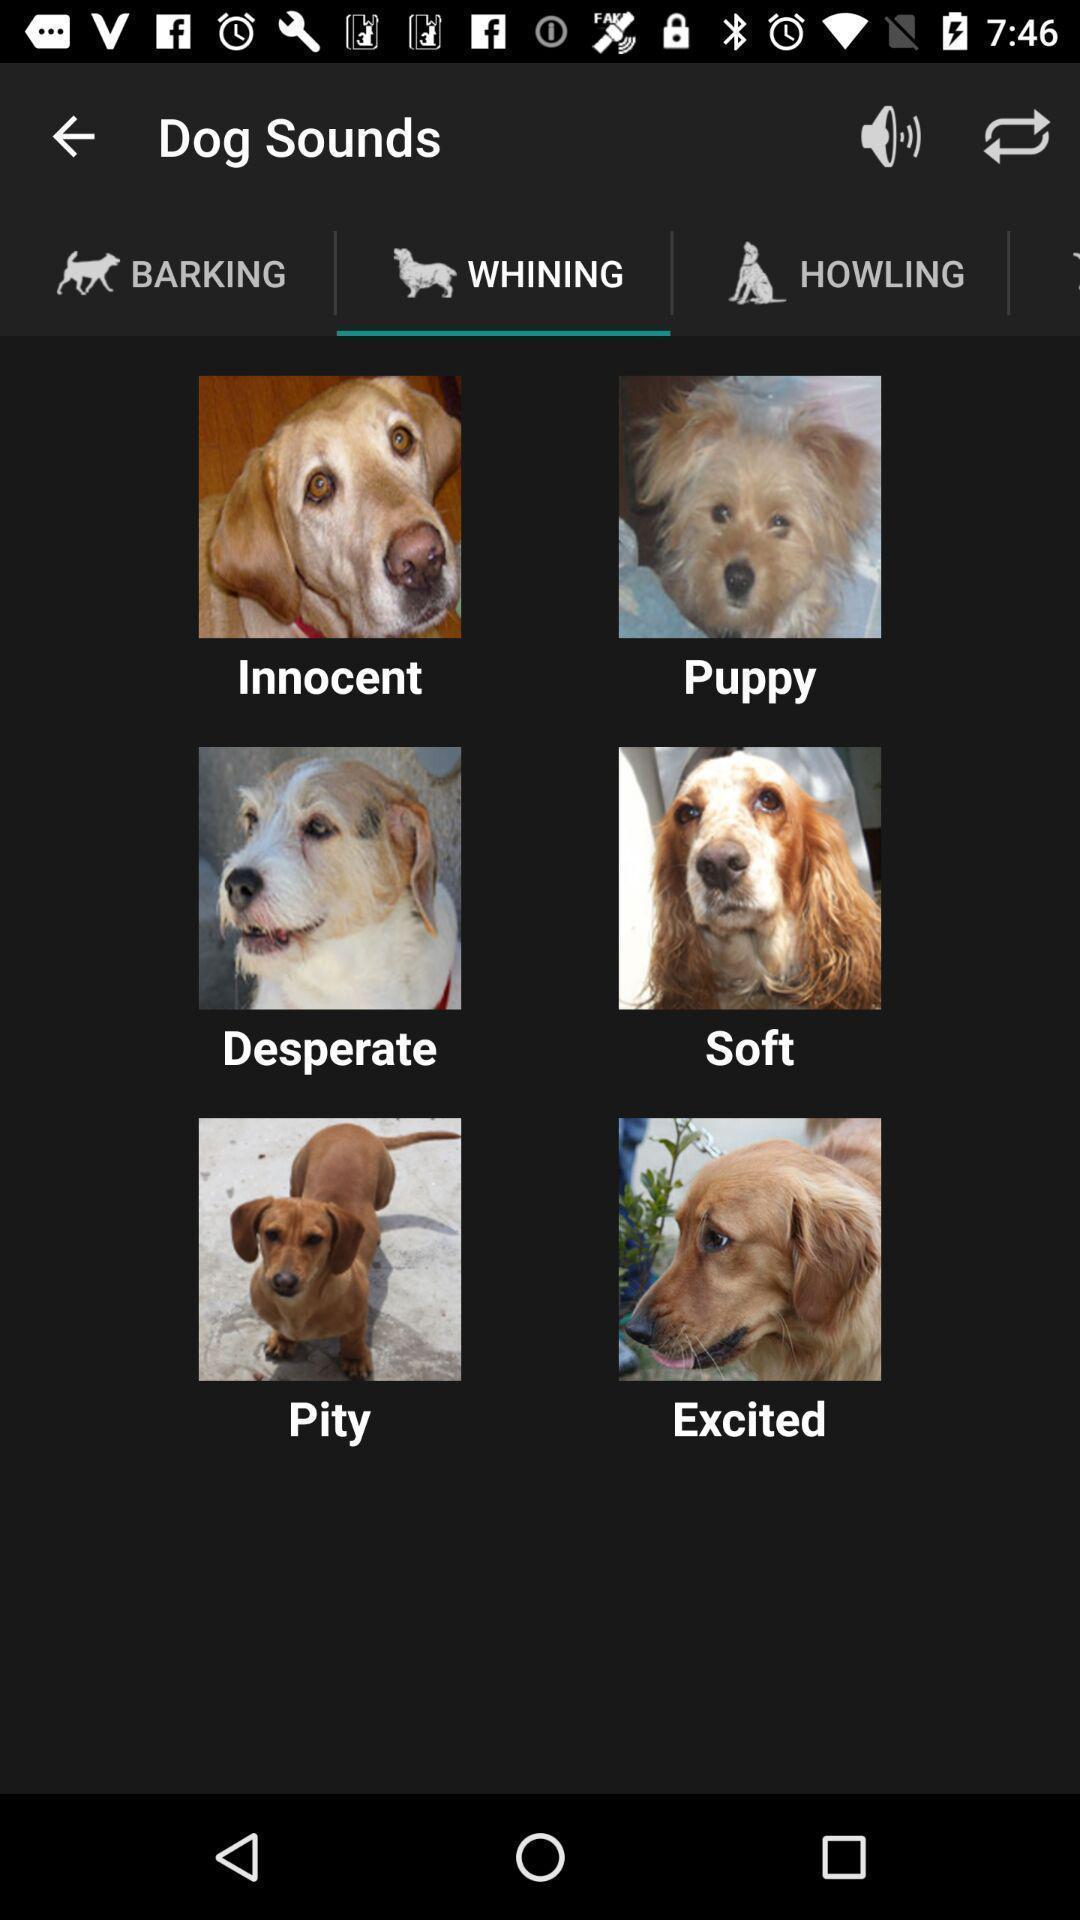Provide a detailed account of this screenshot. Screen displaying multiple images of pet animals. 